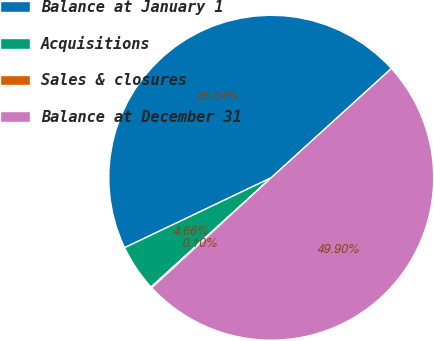<chart> <loc_0><loc_0><loc_500><loc_500><pie_chart><fcel>Balance at January 1<fcel>Acquisitions<fcel>Sales & closures<fcel>Balance at December 31<nl><fcel>45.34%<fcel>4.66%<fcel>0.1%<fcel>49.9%<nl></chart> 